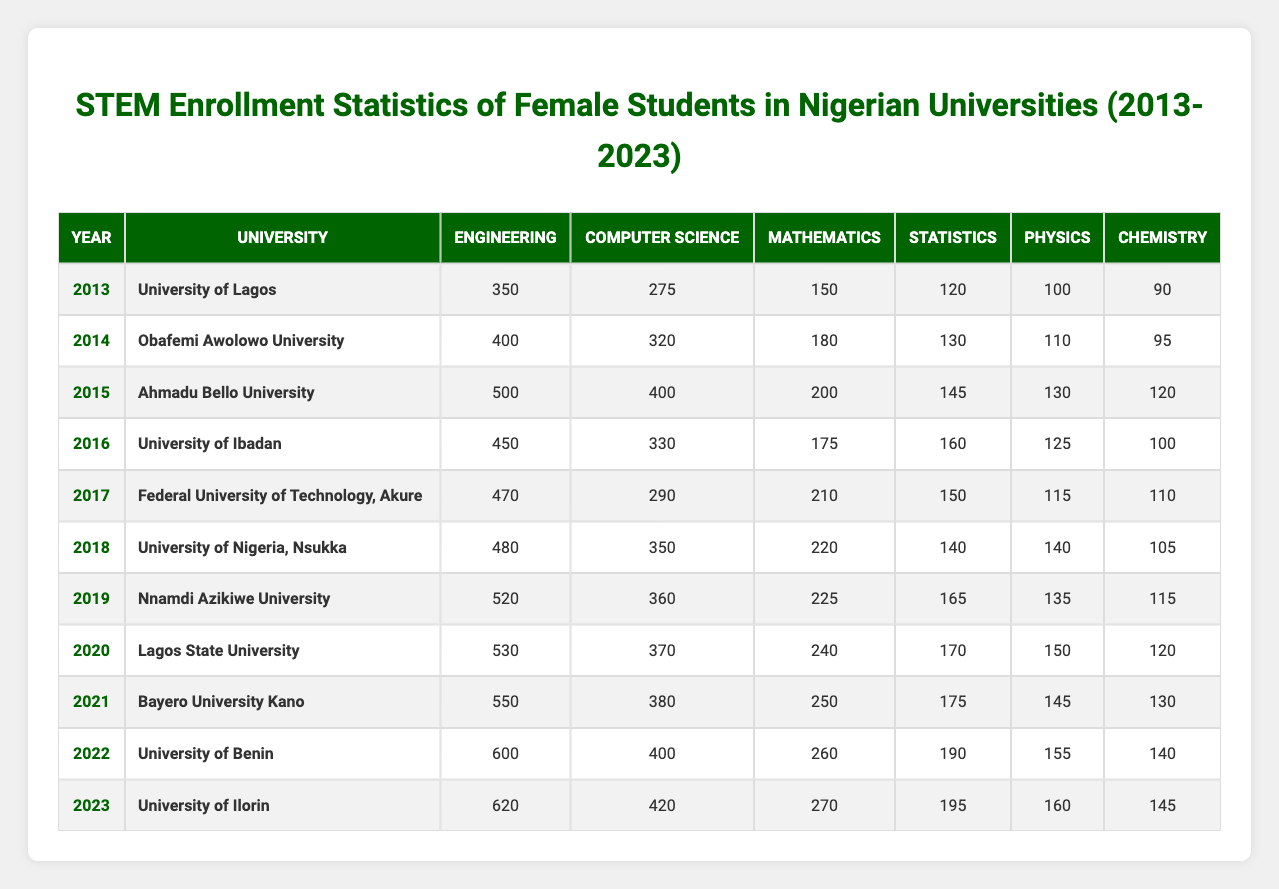What university had the highest enrollment in engineering in 2023? In the year 2023, the University of Ilorin had the highest enrollment in engineering with 620 students, as indicated in the table.
Answer: University of Ilorin What was the total enrollment of female students in science disciplines (Mathematics, Statistics, Physics, Chemistry) at the University of Lagos in 2013? For the University of Lagos in 2013, the total enrollment in science disciplines can be calculated by adding all relevant figures: Mathematics (150) + Statistics (120) + Physics (100) + Chemistry (90) = 460.
Answer: 460 Which university had the most students enrolled in computer science in 2020? In 2020, Lagos State University had the most students enrolled in computer science with 370 students, based on the data provided in the table.
Answer: Lagos State University Did the number of female students in Mathematics increase every year from 2013 to 2023? A comparison of the Mathematics enrollment from 2013 (150) to 2023 (270) shows an increase every year, verifying that the count rose consistently over the decade.
Answer: Yes What was the average enrollment in statistics across all universities from 2013 to 2023? By summing the enrollment figures in statistics for each year (120 + 130 + 145 + 160 + 150 + 140 + 165 + 170 + 175 + 190 + 195) and dividing by 11 (the number of years), the average is calculated as 156.36.
Answer: 156.36 Which year had the lowest number of enrollments in chemistry across all universities? Referring to the table reveals that the lowest enrollment in chemistry was in 2013, with just 90 students at the University of Lagos.
Answer: 90 How many more female students enrolled in computer science at the University of Benin than at the Federal University of Technology, Akure in 2022? To find the difference, we look at the enrollments: University of Benin had 400 in computer science and the Federal University of Technology, Akure had 290 in the same year. Thus, the difference is 400 - 290 = 110.
Answer: 110 Which university had the highest overall enrollment in STEM disciplines in 2022? The total enrollment across disciplines for University of Benin in 2022 is 600 (engineering) + 400 (computer science) + 260 (mathematics) + 190 (statistics) + 155 (physics) + 140 (chemistry) = 1845, which is the highest compared to other universities.
Answer: University of Benin Was there an increase in female student enrollments in engineering from 2013 to 2023 in Nigeria? By comparing enrollment figures from 2013 (350) to 2023 (620), we see that there was a steady increase in enrollment in engineering over the years, showing growth in this field.
Answer: Yes What is the total number of female students enrolled in Physics across all universities in 2019? Summing the Physics enrollments for the year 2019 from various universities: 135 (Nnamdi Azikiwe University). No other universities are listed for that year in the provided data. Therefore, the total is 135.
Answer: 135 How many years did the enrollment in statistics exceed 150 students? Looking at the statistics enrollments, it exceeds 150 in the years 2016 (160), 2017 (150), 2018 (140), 2019 (165), 2020 (170), 2021 (175), 2022 (190), and 2023 (195), totaling 7 years.
Answer: 7 